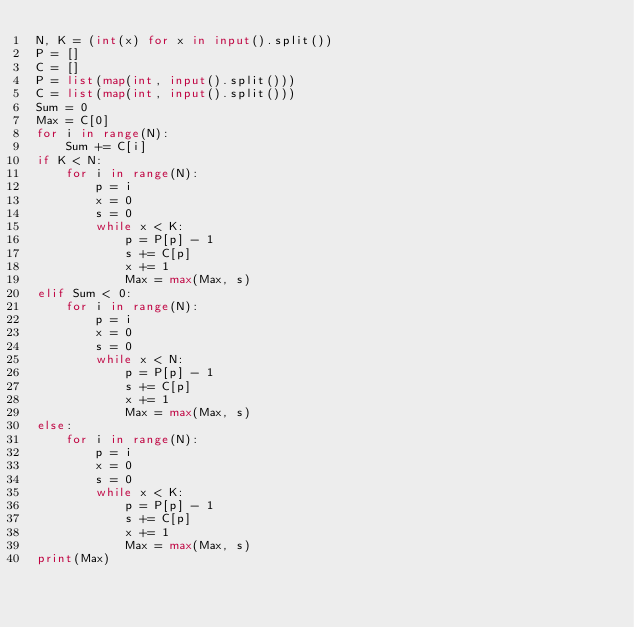Convert code to text. <code><loc_0><loc_0><loc_500><loc_500><_Python_>N, K = (int(x) for x in input().split())
P = []
C = []
P = list(map(int, input().split()))
C = list(map(int, input().split()))
Sum = 0
Max = C[0]
for i in range(N):
    Sum += C[i]
if K < N:
    for i in range(N):
        p = i
        x = 0
        s = 0
        while x < K:
            p = P[p] - 1
            s += C[p]
            x += 1
            Max = max(Max, s)
elif Sum < 0:
    for i in range(N):
        p = i
        x = 0
        s = 0
        while x < N:
            p = P[p] - 1
            s += C[p]
            x += 1
            Max = max(Max, s)
else:
    for i in range(N):
        p = i
        x = 0
        s = 0
        while x < K:
            p = P[p] - 1
            s += C[p]
            x += 1
            Max = max(Max, s)
print(Max)
    


</code> 